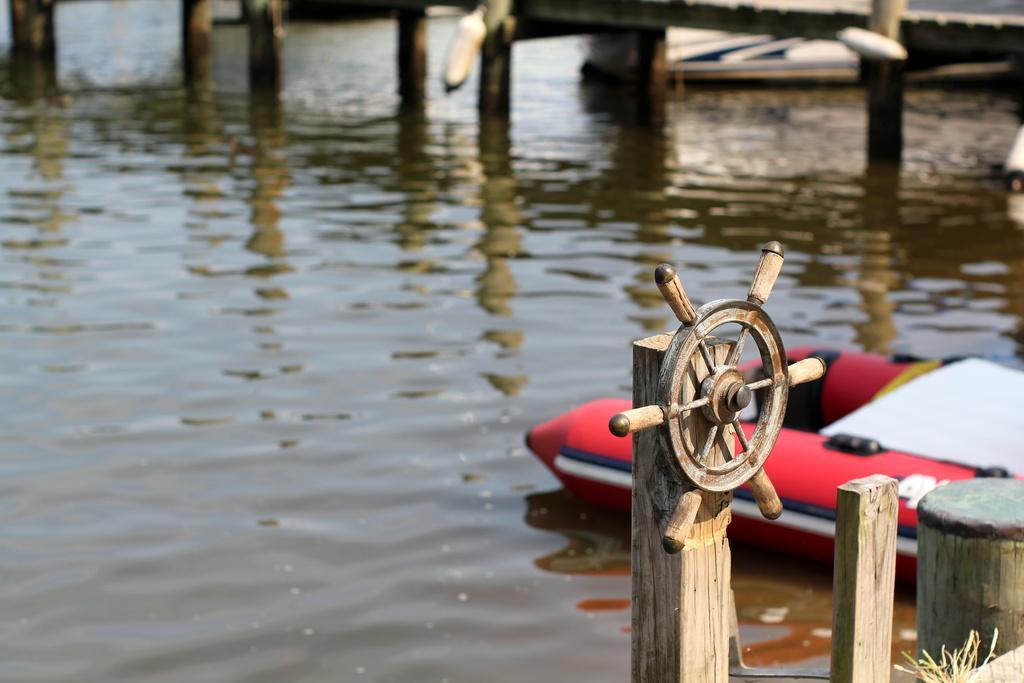Could you give a brief overview of what you see in this image? This image consists of water. In the front, we can see the pillars of a bridge. On the right, there is a boat. And we can see a wheel fixed to a wooden piece. 